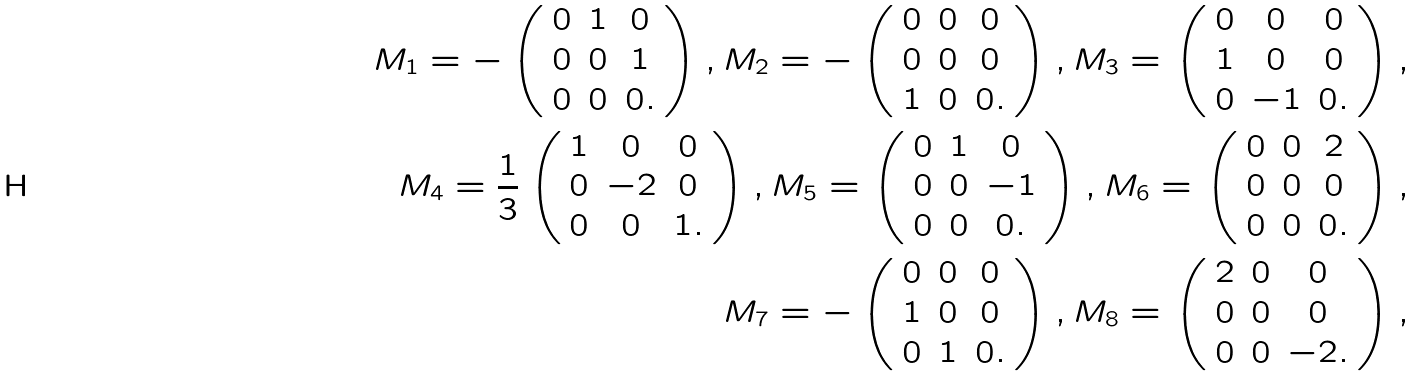Convert formula to latex. <formula><loc_0><loc_0><loc_500><loc_500>M _ { 1 } = - \left ( \begin{array} { c c c } 0 & 1 & 0 \\ 0 & 0 & 1 \\ 0 & 0 & 0 . \end{array} \right ) , M _ { 2 } = - \left ( \begin{array} { c c c } 0 & 0 & 0 \\ 0 & 0 & 0 \\ 1 & 0 & 0 . \end{array} \right ) , M _ { 3 } = \left ( \begin{array} { c c c } 0 & 0 & 0 \\ 1 & 0 & 0 \\ 0 & - 1 & 0 . \end{array} \right ) , \\ M _ { 4 } = \frac { 1 } { 3 } \left ( \begin{array} { c c c } 1 & 0 & 0 \\ 0 & - 2 & 0 \\ 0 & 0 & 1 . \end{array} \right ) , M _ { 5 } = \left ( \begin{array} { c c c } 0 & 1 & 0 \\ 0 & 0 & - 1 \\ 0 & 0 & 0 . \end{array} \right ) , M _ { 6 } = \left ( \begin{array} { c c c } 0 & 0 & 2 \\ 0 & 0 & 0 \\ 0 & 0 & 0 . \end{array} \right ) , \\ M _ { 7 } = - \left ( \begin{array} { c c c } 0 & 0 & 0 \\ 1 & 0 & 0 \\ 0 & 1 & 0 . \end{array} \right ) , M _ { 8 } = \left ( \begin{array} { c c c } 2 & 0 & 0 \\ 0 & 0 & 0 \\ 0 & 0 & - 2 . \end{array} \right ) ,</formula> 